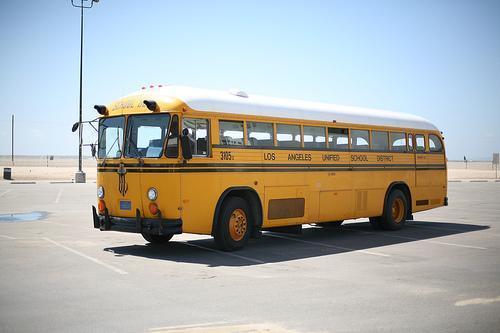How many buses?
Give a very brief answer. 1. 